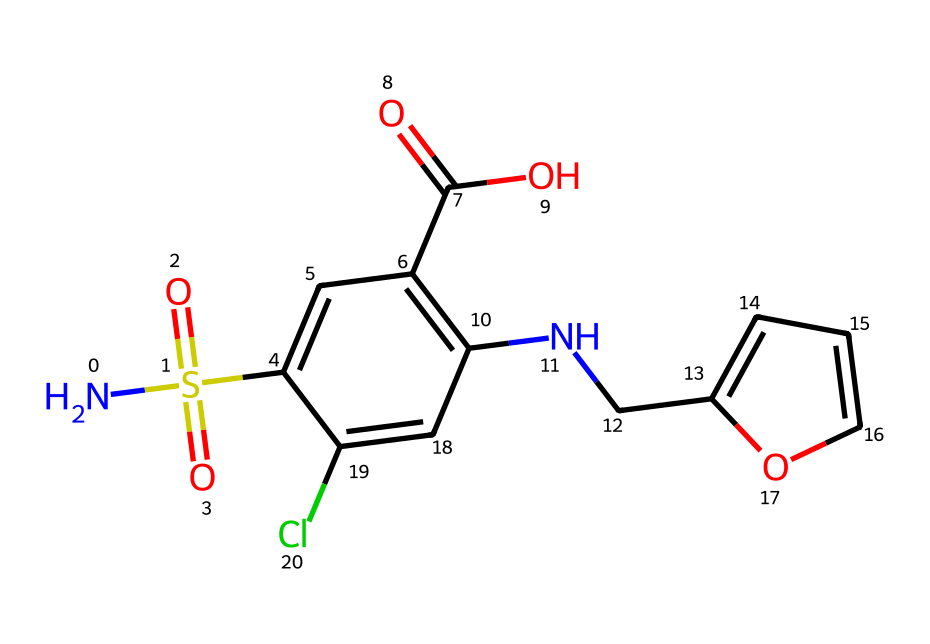What is the molecular formula of furosemide? By analyzing the SMILES representation, we can deduce the molecular formula by counting the types of atoms present. In the structure, there are carbons, hydrogens, nitrogens, oxygens, sulfur, and chlorine. The count leads to the molecular formula C  13 H  14 Cl N  3 O  5 S.
Answer: C13H14ClN3O5S How many nitrogen atoms are present? Looking at the SMILES representation, I can identify two nitrogen atoms (#N). This is evidenced by the presence of 'N' in the string, where I count each occurrence.
Answer: 2 What type of functional groups are present in furosemide? The functional groups identified from the structure include sulfonamide (NS(=O)(=O)), carboxylic acid (C(=O)O), and a phenolic hydroxyl group (due to the ring). Each of these contributes to the chemical's properties.
Answer: sulfonamide, carboxylic acid, phenolic hydroxyl group Does this chemical contain a chlorine atom? In the SMILES representation, the letter 'Cl' indicates the presence of chlorine. This indicates there is one chlorine atom in the structure.
Answer: Yes What is the significance of the sulfonamide group in furosemide? The sulfonamide group (NS(=O)(=O)) plays a crucial role as it is responsible for the diuretic properties of furosemide. This functional group influences its mechanism of action in the body, particularly in inhibiting the transport of sodium.
Answer: Diuretic properties How does furosemide interact with water molecules? The presence of the sulfonamide and carboxylic acid functional groups contributes to its solubility in water. These groups can form hydrogen bonds with water molecules, facilitating their interaction. Hence, the structure's functional groups are hydrophilic.
Answer: Hydrophilic 